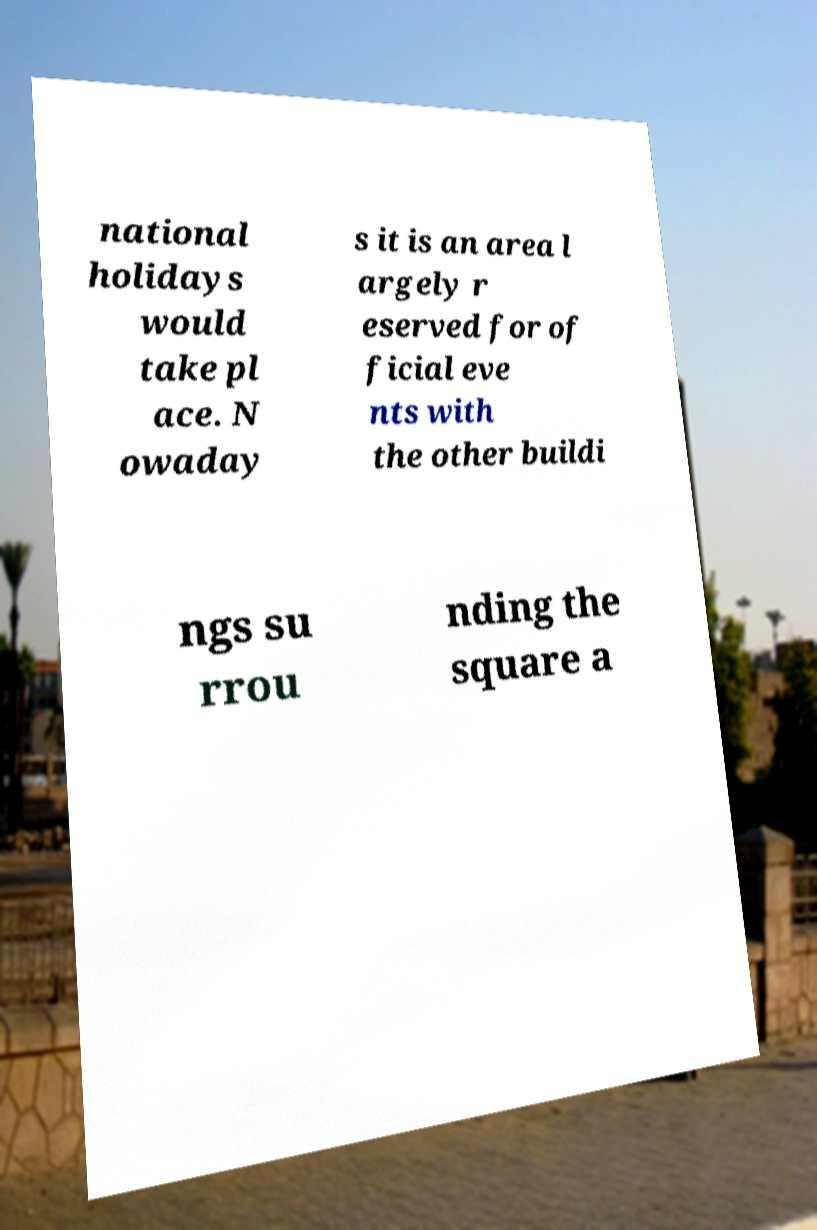What messages or text are displayed in this image? I need them in a readable, typed format. national holidays would take pl ace. N owaday s it is an area l argely r eserved for of ficial eve nts with the other buildi ngs su rrou nding the square a 